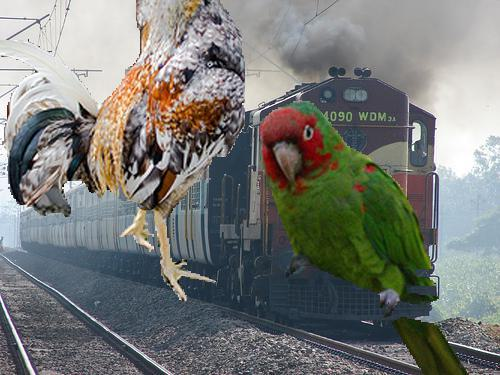What is the significance of the train in this image? The train represents a mode of transportation and industrial progress, and its presence in the image juxtaposed with the birds might suggest a contrast between technology and nature. 